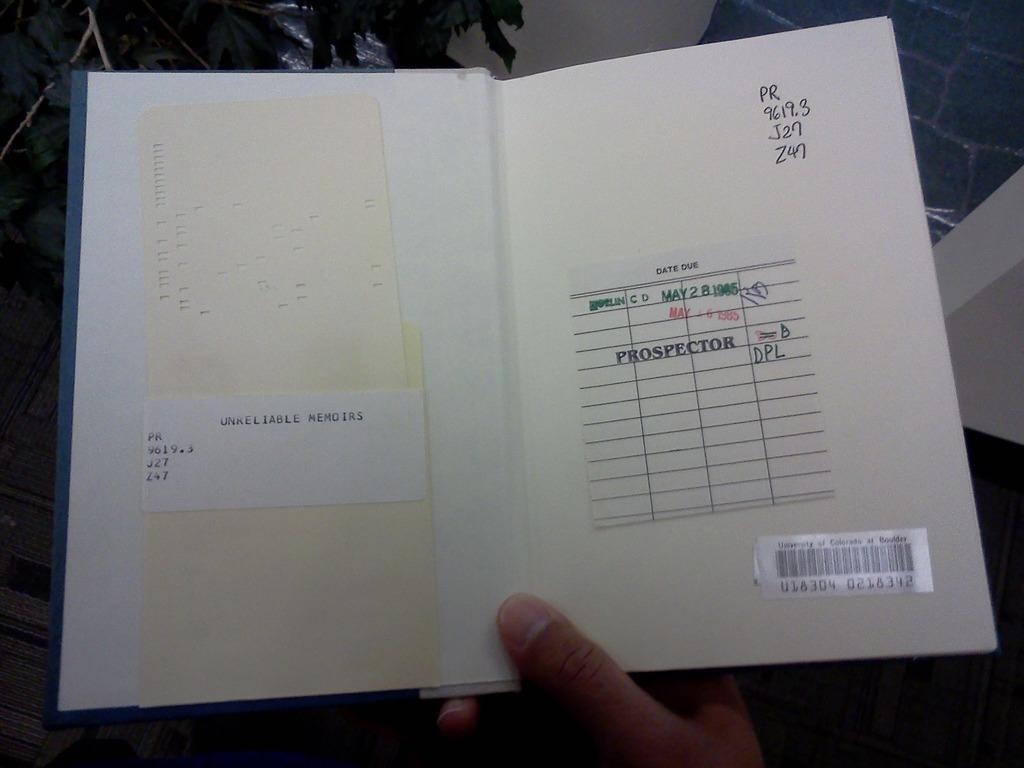<image>
Relay a brief, clear account of the picture shown. Two open pages with the word Prospector on the right side. 